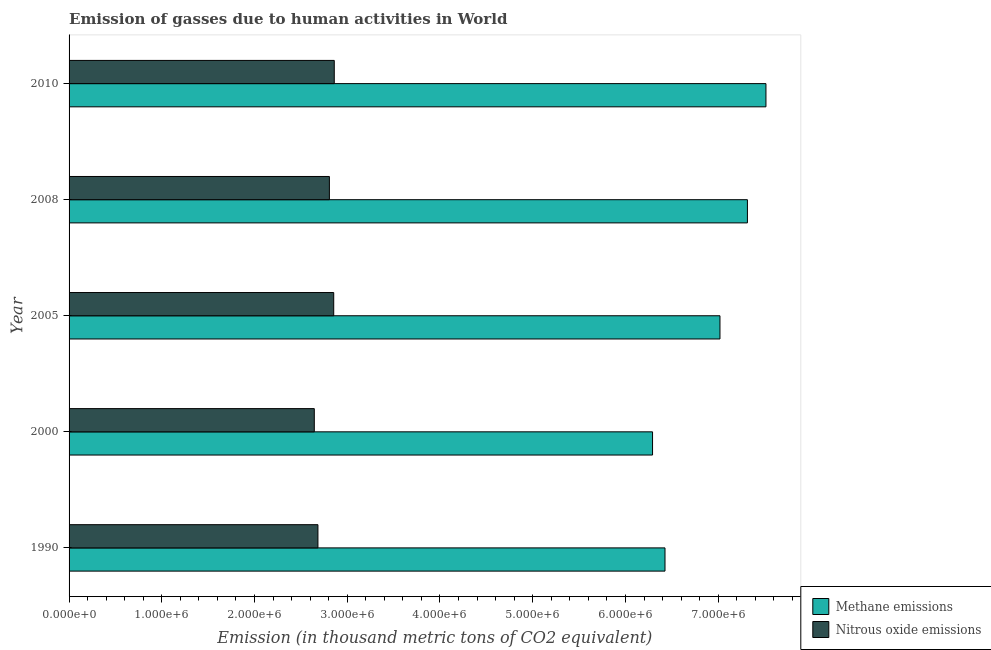Are the number of bars on each tick of the Y-axis equal?
Your answer should be very brief. Yes. How many bars are there on the 3rd tick from the top?
Offer a very short reply. 2. What is the label of the 1st group of bars from the top?
Give a very brief answer. 2010. What is the amount of nitrous oxide emissions in 1990?
Give a very brief answer. 2.68e+06. Across all years, what is the maximum amount of methane emissions?
Ensure brevity in your answer.  7.52e+06. Across all years, what is the minimum amount of nitrous oxide emissions?
Give a very brief answer. 2.64e+06. In which year was the amount of methane emissions maximum?
Make the answer very short. 2010. What is the total amount of methane emissions in the graph?
Make the answer very short. 3.46e+07. What is the difference between the amount of methane emissions in 1990 and that in 2008?
Provide a succinct answer. -8.89e+05. What is the difference between the amount of nitrous oxide emissions in 2010 and the amount of methane emissions in 1990?
Make the answer very short. -3.57e+06. What is the average amount of nitrous oxide emissions per year?
Your answer should be very brief. 2.77e+06. In the year 2008, what is the difference between the amount of methane emissions and amount of nitrous oxide emissions?
Keep it short and to the point. 4.51e+06. What is the ratio of the amount of nitrous oxide emissions in 2000 to that in 2008?
Make the answer very short. 0.94. Is the difference between the amount of methane emissions in 2000 and 2010 greater than the difference between the amount of nitrous oxide emissions in 2000 and 2010?
Provide a succinct answer. No. What is the difference between the highest and the second highest amount of methane emissions?
Make the answer very short. 2.00e+05. What is the difference between the highest and the lowest amount of nitrous oxide emissions?
Offer a terse response. 2.15e+05. Is the sum of the amount of methane emissions in 2005 and 2008 greater than the maximum amount of nitrous oxide emissions across all years?
Your answer should be very brief. Yes. What does the 2nd bar from the top in 2008 represents?
Your answer should be compact. Methane emissions. What does the 1st bar from the bottom in 2000 represents?
Offer a very short reply. Methane emissions. How many bars are there?
Your response must be concise. 10. What is the difference between two consecutive major ticks on the X-axis?
Offer a terse response. 1.00e+06. Are the values on the major ticks of X-axis written in scientific E-notation?
Offer a very short reply. Yes. Where does the legend appear in the graph?
Provide a succinct answer. Bottom right. How many legend labels are there?
Ensure brevity in your answer.  2. What is the title of the graph?
Your answer should be very brief. Emission of gasses due to human activities in World. Does "Under five" appear as one of the legend labels in the graph?
Make the answer very short. No. What is the label or title of the X-axis?
Make the answer very short. Emission (in thousand metric tons of CO2 equivalent). What is the Emission (in thousand metric tons of CO2 equivalent) in Methane emissions in 1990?
Provide a short and direct response. 6.43e+06. What is the Emission (in thousand metric tons of CO2 equivalent) of Nitrous oxide emissions in 1990?
Provide a short and direct response. 2.68e+06. What is the Emission (in thousand metric tons of CO2 equivalent) of Methane emissions in 2000?
Your answer should be compact. 6.29e+06. What is the Emission (in thousand metric tons of CO2 equivalent) in Nitrous oxide emissions in 2000?
Your answer should be very brief. 2.64e+06. What is the Emission (in thousand metric tons of CO2 equivalent) in Methane emissions in 2005?
Provide a succinct answer. 7.02e+06. What is the Emission (in thousand metric tons of CO2 equivalent) of Nitrous oxide emissions in 2005?
Your answer should be very brief. 2.85e+06. What is the Emission (in thousand metric tons of CO2 equivalent) in Methane emissions in 2008?
Provide a short and direct response. 7.32e+06. What is the Emission (in thousand metric tons of CO2 equivalent) of Nitrous oxide emissions in 2008?
Offer a very short reply. 2.81e+06. What is the Emission (in thousand metric tons of CO2 equivalent) in Methane emissions in 2010?
Provide a succinct answer. 7.52e+06. What is the Emission (in thousand metric tons of CO2 equivalent) of Nitrous oxide emissions in 2010?
Your response must be concise. 2.86e+06. Across all years, what is the maximum Emission (in thousand metric tons of CO2 equivalent) of Methane emissions?
Give a very brief answer. 7.52e+06. Across all years, what is the maximum Emission (in thousand metric tons of CO2 equivalent) in Nitrous oxide emissions?
Give a very brief answer. 2.86e+06. Across all years, what is the minimum Emission (in thousand metric tons of CO2 equivalent) of Methane emissions?
Make the answer very short. 6.29e+06. Across all years, what is the minimum Emission (in thousand metric tons of CO2 equivalent) of Nitrous oxide emissions?
Give a very brief answer. 2.64e+06. What is the total Emission (in thousand metric tons of CO2 equivalent) in Methane emissions in the graph?
Offer a terse response. 3.46e+07. What is the total Emission (in thousand metric tons of CO2 equivalent) of Nitrous oxide emissions in the graph?
Ensure brevity in your answer.  1.38e+07. What is the difference between the Emission (in thousand metric tons of CO2 equivalent) in Methane emissions in 1990 and that in 2000?
Your response must be concise. 1.34e+05. What is the difference between the Emission (in thousand metric tons of CO2 equivalent) of Nitrous oxide emissions in 1990 and that in 2000?
Ensure brevity in your answer.  3.92e+04. What is the difference between the Emission (in thousand metric tons of CO2 equivalent) of Methane emissions in 1990 and that in 2005?
Ensure brevity in your answer.  -5.93e+05. What is the difference between the Emission (in thousand metric tons of CO2 equivalent) of Nitrous oxide emissions in 1990 and that in 2005?
Provide a succinct answer. -1.70e+05. What is the difference between the Emission (in thousand metric tons of CO2 equivalent) of Methane emissions in 1990 and that in 2008?
Offer a terse response. -8.89e+05. What is the difference between the Emission (in thousand metric tons of CO2 equivalent) of Nitrous oxide emissions in 1990 and that in 2008?
Your response must be concise. -1.24e+05. What is the difference between the Emission (in thousand metric tons of CO2 equivalent) of Methane emissions in 1990 and that in 2010?
Provide a succinct answer. -1.09e+06. What is the difference between the Emission (in thousand metric tons of CO2 equivalent) of Nitrous oxide emissions in 1990 and that in 2010?
Make the answer very short. -1.76e+05. What is the difference between the Emission (in thousand metric tons of CO2 equivalent) of Methane emissions in 2000 and that in 2005?
Give a very brief answer. -7.27e+05. What is the difference between the Emission (in thousand metric tons of CO2 equivalent) in Nitrous oxide emissions in 2000 and that in 2005?
Keep it short and to the point. -2.09e+05. What is the difference between the Emission (in thousand metric tons of CO2 equivalent) in Methane emissions in 2000 and that in 2008?
Ensure brevity in your answer.  -1.02e+06. What is the difference between the Emission (in thousand metric tons of CO2 equivalent) of Nitrous oxide emissions in 2000 and that in 2008?
Ensure brevity in your answer.  -1.63e+05. What is the difference between the Emission (in thousand metric tons of CO2 equivalent) in Methane emissions in 2000 and that in 2010?
Offer a very short reply. -1.22e+06. What is the difference between the Emission (in thousand metric tons of CO2 equivalent) in Nitrous oxide emissions in 2000 and that in 2010?
Offer a terse response. -2.15e+05. What is the difference between the Emission (in thousand metric tons of CO2 equivalent) of Methane emissions in 2005 and that in 2008?
Your answer should be very brief. -2.96e+05. What is the difference between the Emission (in thousand metric tons of CO2 equivalent) in Nitrous oxide emissions in 2005 and that in 2008?
Provide a succinct answer. 4.66e+04. What is the difference between the Emission (in thousand metric tons of CO2 equivalent) in Methane emissions in 2005 and that in 2010?
Your response must be concise. -4.96e+05. What is the difference between the Emission (in thousand metric tons of CO2 equivalent) in Nitrous oxide emissions in 2005 and that in 2010?
Offer a very short reply. -5911.5. What is the difference between the Emission (in thousand metric tons of CO2 equivalent) in Methane emissions in 2008 and that in 2010?
Your answer should be compact. -2.00e+05. What is the difference between the Emission (in thousand metric tons of CO2 equivalent) in Nitrous oxide emissions in 2008 and that in 2010?
Ensure brevity in your answer.  -5.25e+04. What is the difference between the Emission (in thousand metric tons of CO2 equivalent) of Methane emissions in 1990 and the Emission (in thousand metric tons of CO2 equivalent) of Nitrous oxide emissions in 2000?
Make the answer very short. 3.78e+06. What is the difference between the Emission (in thousand metric tons of CO2 equivalent) in Methane emissions in 1990 and the Emission (in thousand metric tons of CO2 equivalent) in Nitrous oxide emissions in 2005?
Keep it short and to the point. 3.57e+06. What is the difference between the Emission (in thousand metric tons of CO2 equivalent) of Methane emissions in 1990 and the Emission (in thousand metric tons of CO2 equivalent) of Nitrous oxide emissions in 2008?
Offer a terse response. 3.62e+06. What is the difference between the Emission (in thousand metric tons of CO2 equivalent) of Methane emissions in 1990 and the Emission (in thousand metric tons of CO2 equivalent) of Nitrous oxide emissions in 2010?
Provide a succinct answer. 3.57e+06. What is the difference between the Emission (in thousand metric tons of CO2 equivalent) of Methane emissions in 2000 and the Emission (in thousand metric tons of CO2 equivalent) of Nitrous oxide emissions in 2005?
Give a very brief answer. 3.44e+06. What is the difference between the Emission (in thousand metric tons of CO2 equivalent) in Methane emissions in 2000 and the Emission (in thousand metric tons of CO2 equivalent) in Nitrous oxide emissions in 2008?
Make the answer very short. 3.48e+06. What is the difference between the Emission (in thousand metric tons of CO2 equivalent) in Methane emissions in 2000 and the Emission (in thousand metric tons of CO2 equivalent) in Nitrous oxide emissions in 2010?
Make the answer very short. 3.43e+06. What is the difference between the Emission (in thousand metric tons of CO2 equivalent) of Methane emissions in 2005 and the Emission (in thousand metric tons of CO2 equivalent) of Nitrous oxide emissions in 2008?
Make the answer very short. 4.21e+06. What is the difference between the Emission (in thousand metric tons of CO2 equivalent) of Methane emissions in 2005 and the Emission (in thousand metric tons of CO2 equivalent) of Nitrous oxide emissions in 2010?
Your answer should be very brief. 4.16e+06. What is the difference between the Emission (in thousand metric tons of CO2 equivalent) of Methane emissions in 2008 and the Emission (in thousand metric tons of CO2 equivalent) of Nitrous oxide emissions in 2010?
Your answer should be compact. 4.46e+06. What is the average Emission (in thousand metric tons of CO2 equivalent) of Methane emissions per year?
Provide a short and direct response. 6.91e+06. What is the average Emission (in thousand metric tons of CO2 equivalent) of Nitrous oxide emissions per year?
Keep it short and to the point. 2.77e+06. In the year 1990, what is the difference between the Emission (in thousand metric tons of CO2 equivalent) in Methane emissions and Emission (in thousand metric tons of CO2 equivalent) in Nitrous oxide emissions?
Provide a succinct answer. 3.74e+06. In the year 2000, what is the difference between the Emission (in thousand metric tons of CO2 equivalent) of Methane emissions and Emission (in thousand metric tons of CO2 equivalent) of Nitrous oxide emissions?
Provide a short and direct response. 3.65e+06. In the year 2005, what is the difference between the Emission (in thousand metric tons of CO2 equivalent) of Methane emissions and Emission (in thousand metric tons of CO2 equivalent) of Nitrous oxide emissions?
Give a very brief answer. 4.17e+06. In the year 2008, what is the difference between the Emission (in thousand metric tons of CO2 equivalent) of Methane emissions and Emission (in thousand metric tons of CO2 equivalent) of Nitrous oxide emissions?
Your answer should be very brief. 4.51e+06. In the year 2010, what is the difference between the Emission (in thousand metric tons of CO2 equivalent) in Methane emissions and Emission (in thousand metric tons of CO2 equivalent) in Nitrous oxide emissions?
Your answer should be very brief. 4.66e+06. What is the ratio of the Emission (in thousand metric tons of CO2 equivalent) in Methane emissions in 1990 to that in 2000?
Offer a terse response. 1.02. What is the ratio of the Emission (in thousand metric tons of CO2 equivalent) of Nitrous oxide emissions in 1990 to that in 2000?
Your response must be concise. 1.01. What is the ratio of the Emission (in thousand metric tons of CO2 equivalent) of Methane emissions in 1990 to that in 2005?
Your answer should be compact. 0.92. What is the ratio of the Emission (in thousand metric tons of CO2 equivalent) of Nitrous oxide emissions in 1990 to that in 2005?
Your response must be concise. 0.94. What is the ratio of the Emission (in thousand metric tons of CO2 equivalent) of Methane emissions in 1990 to that in 2008?
Your answer should be compact. 0.88. What is the ratio of the Emission (in thousand metric tons of CO2 equivalent) in Nitrous oxide emissions in 1990 to that in 2008?
Offer a very short reply. 0.96. What is the ratio of the Emission (in thousand metric tons of CO2 equivalent) of Methane emissions in 1990 to that in 2010?
Make the answer very short. 0.86. What is the ratio of the Emission (in thousand metric tons of CO2 equivalent) in Nitrous oxide emissions in 1990 to that in 2010?
Give a very brief answer. 0.94. What is the ratio of the Emission (in thousand metric tons of CO2 equivalent) of Methane emissions in 2000 to that in 2005?
Offer a terse response. 0.9. What is the ratio of the Emission (in thousand metric tons of CO2 equivalent) in Nitrous oxide emissions in 2000 to that in 2005?
Your response must be concise. 0.93. What is the ratio of the Emission (in thousand metric tons of CO2 equivalent) in Methane emissions in 2000 to that in 2008?
Keep it short and to the point. 0.86. What is the ratio of the Emission (in thousand metric tons of CO2 equivalent) in Nitrous oxide emissions in 2000 to that in 2008?
Offer a terse response. 0.94. What is the ratio of the Emission (in thousand metric tons of CO2 equivalent) in Methane emissions in 2000 to that in 2010?
Your answer should be very brief. 0.84. What is the ratio of the Emission (in thousand metric tons of CO2 equivalent) in Nitrous oxide emissions in 2000 to that in 2010?
Make the answer very short. 0.92. What is the ratio of the Emission (in thousand metric tons of CO2 equivalent) of Methane emissions in 2005 to that in 2008?
Offer a very short reply. 0.96. What is the ratio of the Emission (in thousand metric tons of CO2 equivalent) of Nitrous oxide emissions in 2005 to that in 2008?
Ensure brevity in your answer.  1.02. What is the ratio of the Emission (in thousand metric tons of CO2 equivalent) of Methane emissions in 2005 to that in 2010?
Offer a very short reply. 0.93. What is the ratio of the Emission (in thousand metric tons of CO2 equivalent) of Nitrous oxide emissions in 2005 to that in 2010?
Offer a very short reply. 1. What is the ratio of the Emission (in thousand metric tons of CO2 equivalent) of Methane emissions in 2008 to that in 2010?
Your answer should be compact. 0.97. What is the ratio of the Emission (in thousand metric tons of CO2 equivalent) in Nitrous oxide emissions in 2008 to that in 2010?
Make the answer very short. 0.98. What is the difference between the highest and the second highest Emission (in thousand metric tons of CO2 equivalent) of Methane emissions?
Provide a short and direct response. 2.00e+05. What is the difference between the highest and the second highest Emission (in thousand metric tons of CO2 equivalent) in Nitrous oxide emissions?
Offer a terse response. 5911.5. What is the difference between the highest and the lowest Emission (in thousand metric tons of CO2 equivalent) of Methane emissions?
Your answer should be compact. 1.22e+06. What is the difference between the highest and the lowest Emission (in thousand metric tons of CO2 equivalent) in Nitrous oxide emissions?
Make the answer very short. 2.15e+05. 